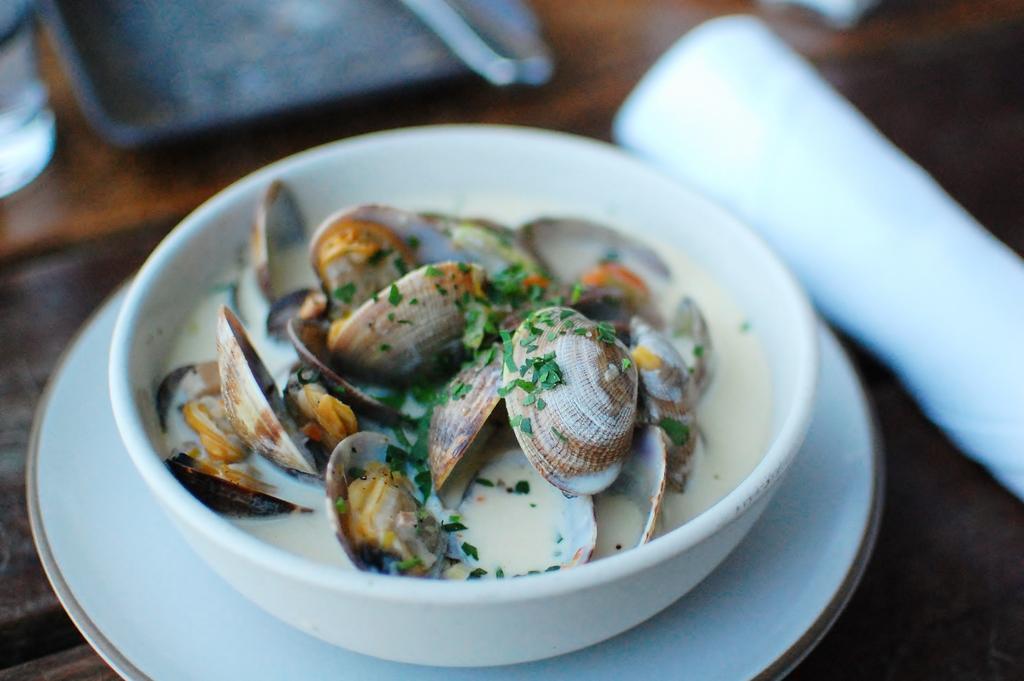Can you describe this image briefly? In this image I can see the bowl with food. The bowl is on the plate. To the side I can see the tray and few more objects. These are on the brown color surface. 